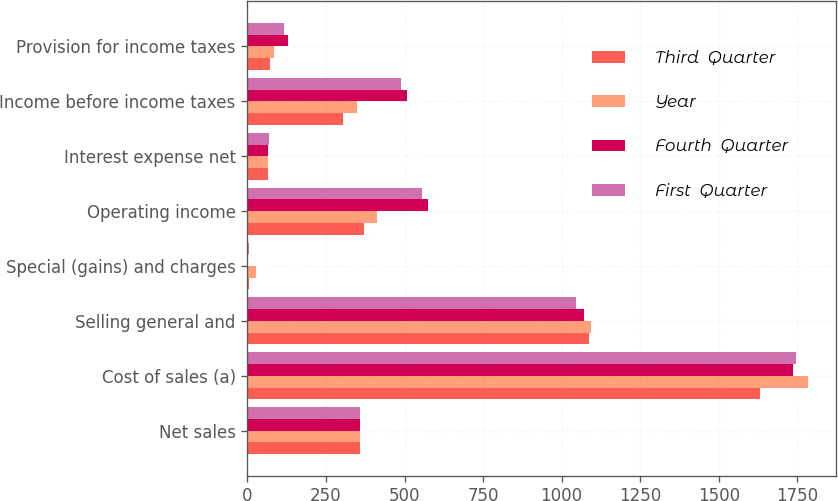<chart> <loc_0><loc_0><loc_500><loc_500><stacked_bar_chart><ecel><fcel>Net sales<fcel>Cost of sales (a)<fcel>Selling general and<fcel>Special (gains) and charges<fcel>Operating income<fcel>Interest expense net<fcel>Income before income taxes<fcel>Provision for income taxes<nl><fcel>Third  Quarter<fcel>359.35<fcel>1631.4<fcel>1088.2<fcel>6.3<fcel>371.5<fcel>66.1<fcel>305.4<fcel>73.4<nl><fcel>Year<fcel>359.35<fcel>1785.2<fcel>1093.3<fcel>26.2<fcel>412.5<fcel>65.3<fcel>347.2<fcel>83.6<nl><fcel>Fourth  Quarter<fcel>359.35<fcel>1737.2<fcel>1071.6<fcel>3.2<fcel>574.1<fcel>64.9<fcel>509.2<fcel>129.7<nl><fcel>First  Quarter<fcel>359.35<fcel>1745.1<fcel>1046.3<fcel>3.8<fcel>556.9<fcel>68.3<fcel>488.6<fcel>116.6<nl></chart> 